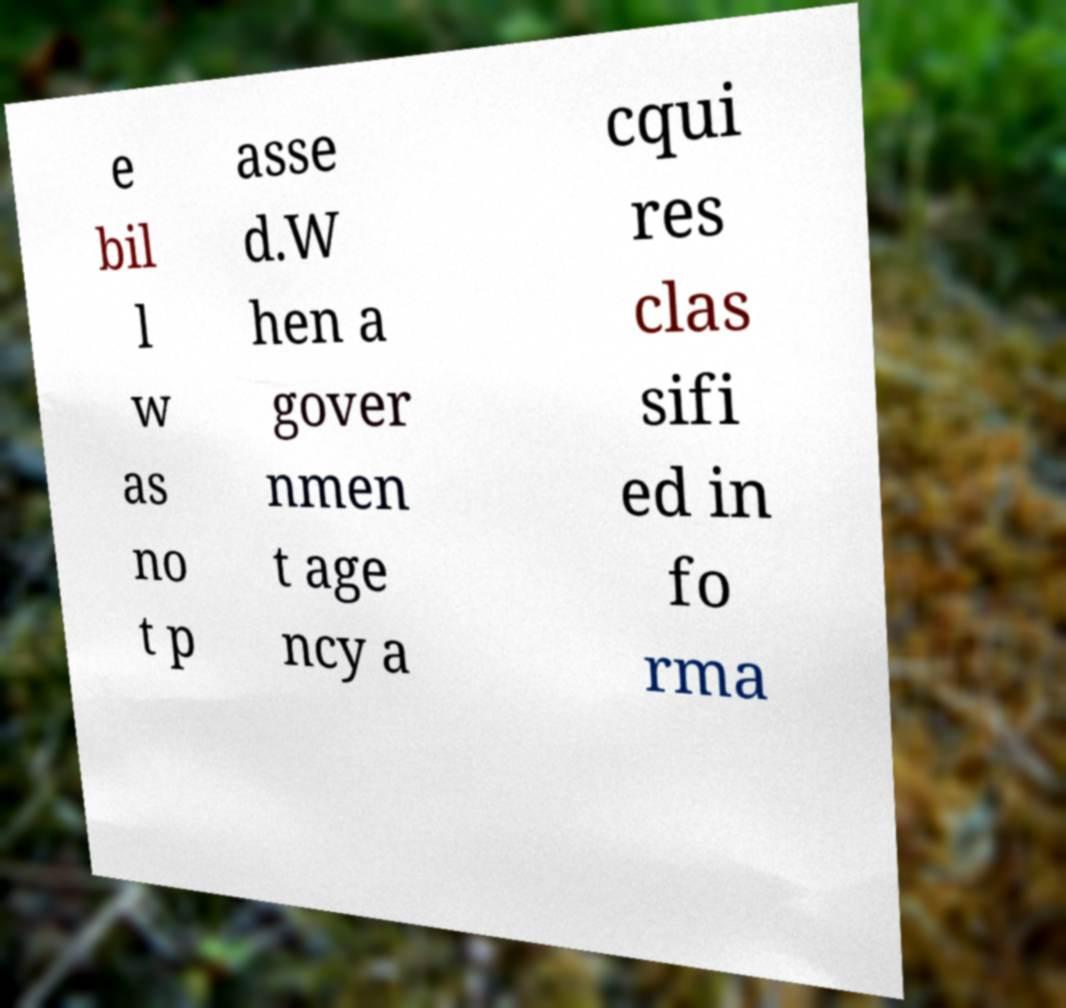Could you assist in decoding the text presented in this image and type it out clearly? e bil l w as no t p asse d.W hen a gover nmen t age ncy a cqui res clas sifi ed in fo rma 